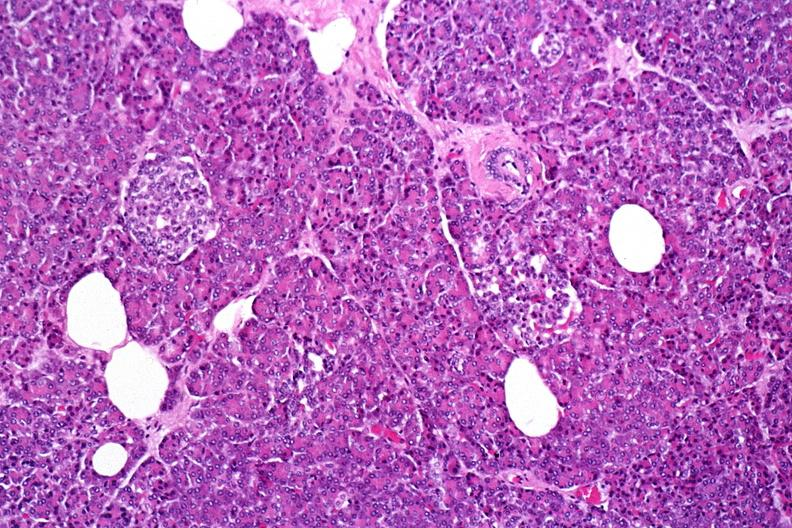does ulcer with candida infection show normal pancreas?
Answer the question using a single word or phrase. No 